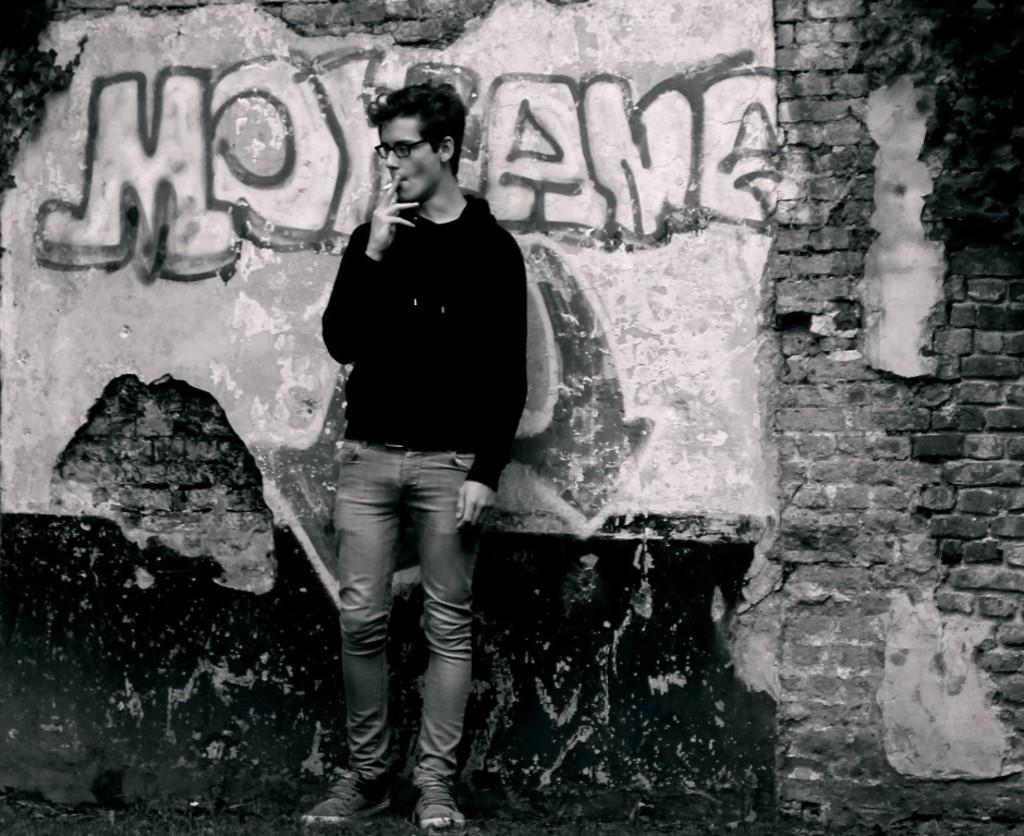In one or two sentences, can you explain what this image depicts? In this image we can see a person. A person is smoking in the image. There is some text written on the wall. 